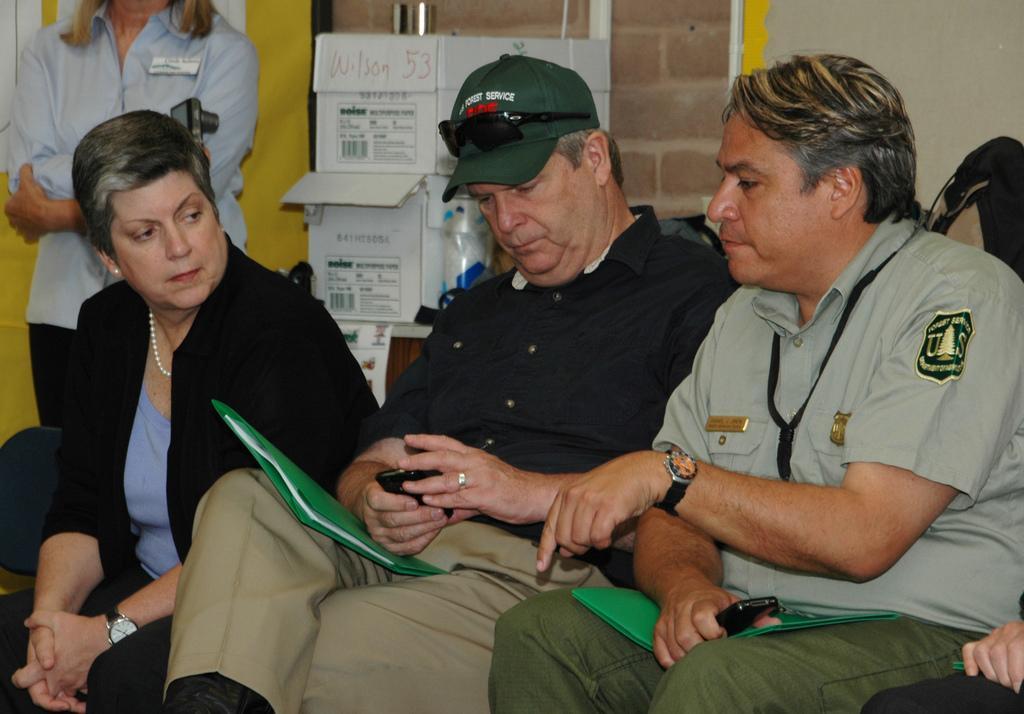Can you describe this image briefly? This picture might be taken from inside the room. In this image, we can see three people are sitting on the chair. On the right corner, we can also see a hand and leg of a person. On the left side, we can see a woman standing. In the background, we can see some boxes and a wall. 